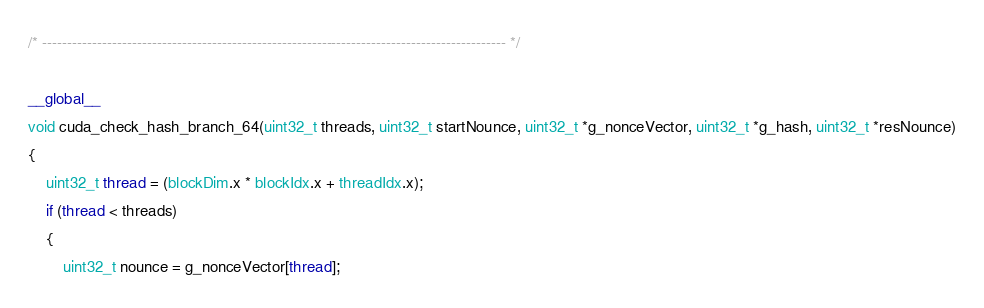<code> <loc_0><loc_0><loc_500><loc_500><_Cuda_>/* --------------------------------------------------------------------------------------------- */

__global__
void cuda_check_hash_branch_64(uint32_t threads, uint32_t startNounce, uint32_t *g_nonceVector, uint32_t *g_hash, uint32_t *resNounce)
{
	uint32_t thread = (blockDim.x * blockIdx.x + threadIdx.x);
	if (thread < threads)
	{
		uint32_t nounce = g_nonceVector[thread];</code> 